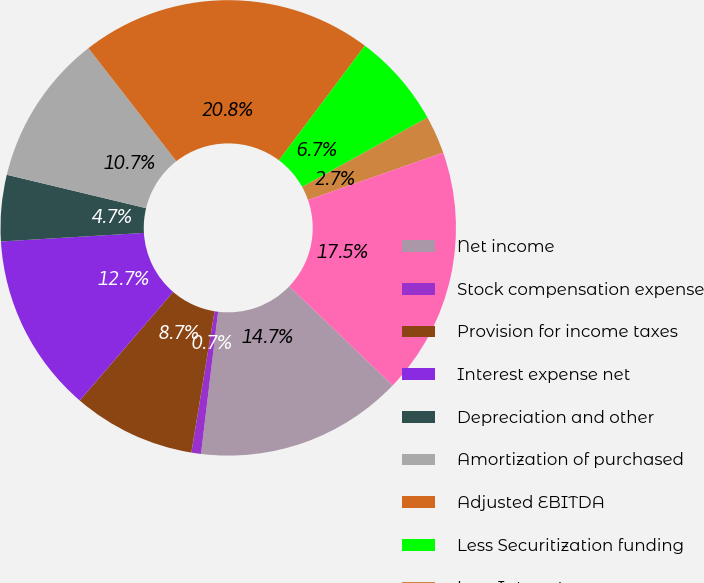Convert chart. <chart><loc_0><loc_0><loc_500><loc_500><pie_chart><fcel>Net income<fcel>Stock compensation expense<fcel>Provision for income taxes<fcel>Interest expense net<fcel>Depreciation and other<fcel>Amortization of purchased<fcel>Adjusted EBITDA<fcel>Less Securitization funding<fcel>Less Interest expense on<fcel>Adjusted EBITDA net<nl><fcel>14.75%<fcel>0.68%<fcel>8.72%<fcel>12.74%<fcel>4.7%<fcel>10.73%<fcel>20.77%<fcel>6.71%<fcel>2.69%<fcel>17.52%<nl></chart> 